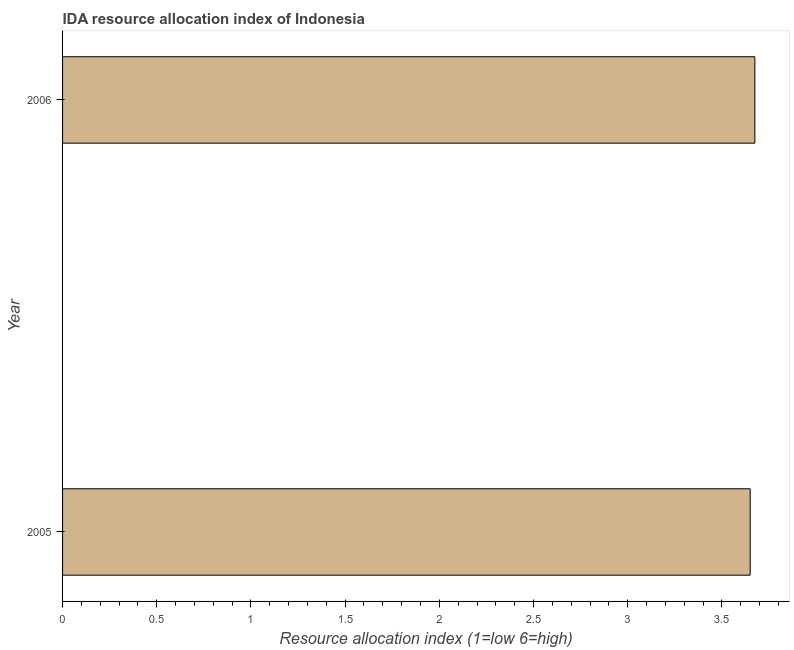What is the title of the graph?
Offer a very short reply. IDA resource allocation index of Indonesia. What is the label or title of the X-axis?
Ensure brevity in your answer.  Resource allocation index (1=low 6=high). What is the ida resource allocation index in 2005?
Provide a short and direct response. 3.65. Across all years, what is the maximum ida resource allocation index?
Your answer should be very brief. 3.67. Across all years, what is the minimum ida resource allocation index?
Provide a short and direct response. 3.65. In which year was the ida resource allocation index minimum?
Offer a very short reply. 2005. What is the sum of the ida resource allocation index?
Offer a very short reply. 7.32. What is the difference between the ida resource allocation index in 2005 and 2006?
Provide a succinct answer. -0.03. What is the average ida resource allocation index per year?
Give a very brief answer. 3.66. What is the median ida resource allocation index?
Ensure brevity in your answer.  3.66. In how many years, is the ida resource allocation index greater than 2.1 ?
Your answer should be very brief. 2. In how many years, is the ida resource allocation index greater than the average ida resource allocation index taken over all years?
Provide a succinct answer. 1. Are all the bars in the graph horizontal?
Your response must be concise. Yes. Are the values on the major ticks of X-axis written in scientific E-notation?
Offer a terse response. No. What is the Resource allocation index (1=low 6=high) in 2005?
Give a very brief answer. 3.65. What is the Resource allocation index (1=low 6=high) in 2006?
Your answer should be very brief. 3.67. What is the difference between the Resource allocation index (1=low 6=high) in 2005 and 2006?
Your response must be concise. -0.03. What is the ratio of the Resource allocation index (1=low 6=high) in 2005 to that in 2006?
Provide a short and direct response. 0.99. 